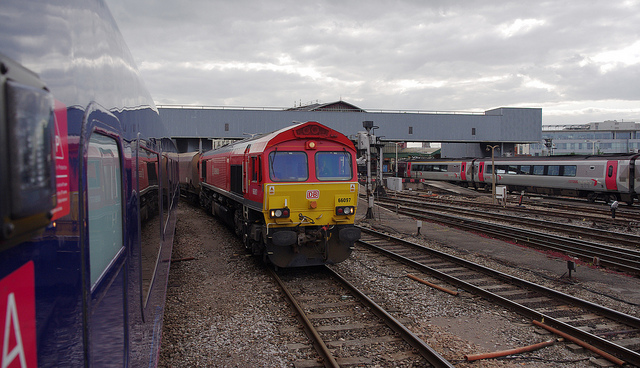Please identify all text content in this image. 08 A 